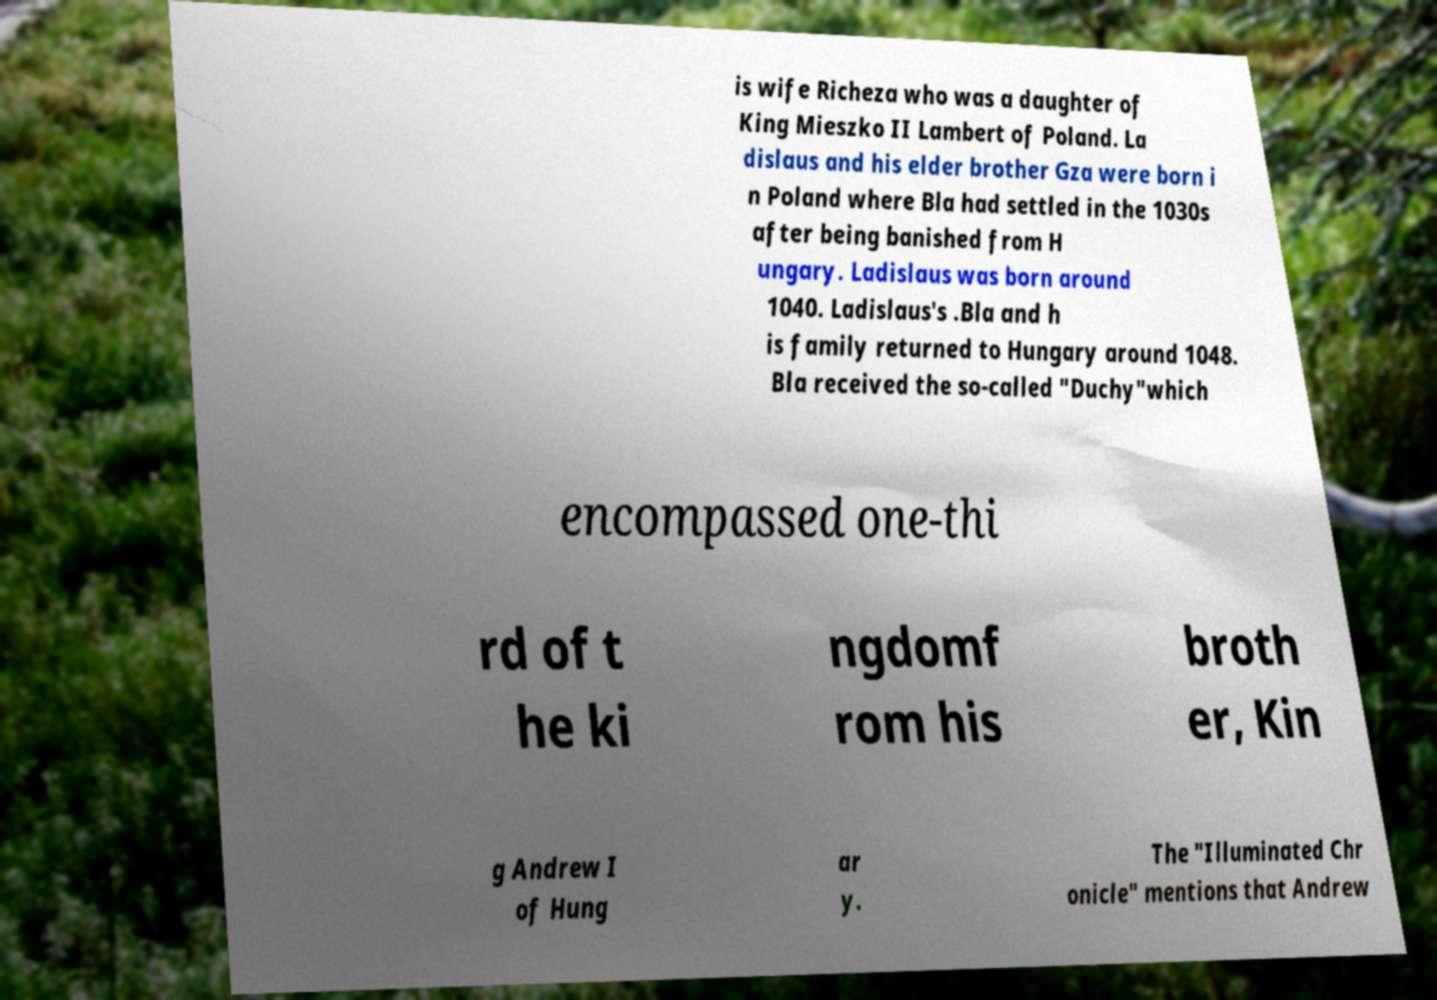Can you accurately transcribe the text from the provided image for me? is wife Richeza who was a daughter of King Mieszko II Lambert of Poland. La dislaus and his elder brother Gza were born i n Poland where Bla had settled in the 1030s after being banished from H ungary. Ladislaus was born around 1040. Ladislaus's .Bla and h is family returned to Hungary around 1048. Bla received the so-called "Duchy"which encompassed one-thi rd of t he ki ngdomf rom his broth er, Kin g Andrew I of Hung ar y. The "Illuminated Chr onicle" mentions that Andrew 